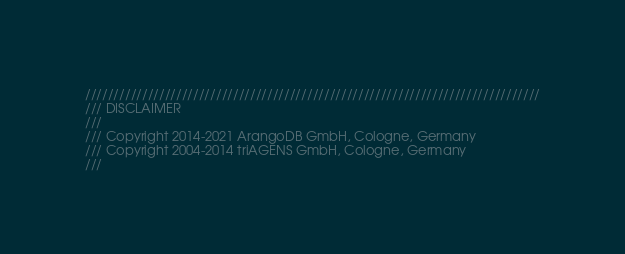Convert code to text. <code><loc_0><loc_0><loc_500><loc_500><_C++_>////////////////////////////////////////////////////////////////////////////////
/// DISCLAIMER
///
/// Copyright 2014-2021 ArangoDB GmbH, Cologne, Germany
/// Copyright 2004-2014 triAGENS GmbH, Cologne, Germany
///</code> 